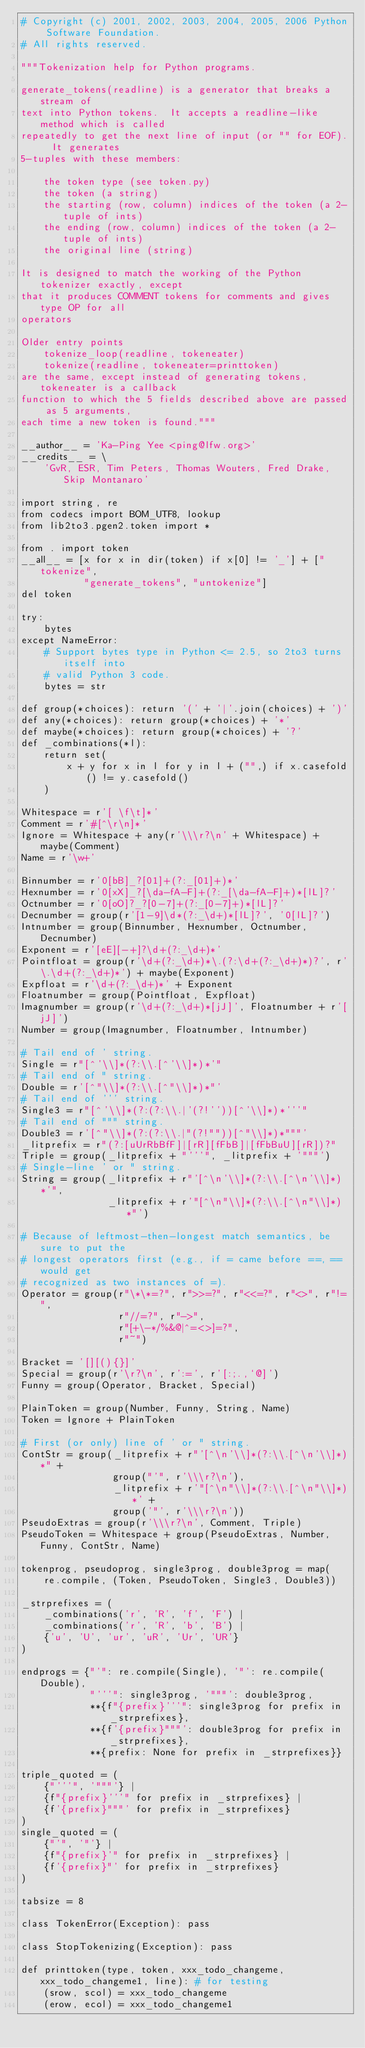<code> <loc_0><loc_0><loc_500><loc_500><_Python_># Copyright (c) 2001, 2002, 2003, 2004, 2005, 2006 Python Software Foundation.
# All rights reserved.

"""Tokenization help for Python programs.

generate_tokens(readline) is a generator that breaks a stream of
text into Python tokens.  It accepts a readline-like method which is called
repeatedly to get the next line of input (or "" for EOF).  It generates
5-tuples with these members:

    the token type (see token.py)
    the token (a string)
    the starting (row, column) indices of the token (a 2-tuple of ints)
    the ending (row, column) indices of the token (a 2-tuple of ints)
    the original line (string)

It is designed to match the working of the Python tokenizer exactly, except
that it produces COMMENT tokens for comments and gives type OP for all
operators

Older entry points
    tokenize_loop(readline, tokeneater)
    tokenize(readline, tokeneater=printtoken)
are the same, except instead of generating tokens, tokeneater is a callback
function to which the 5 fields described above are passed as 5 arguments,
each time a new token is found."""

__author__ = 'Ka-Ping Yee <ping@lfw.org>'
__credits__ = \
    'GvR, ESR, Tim Peters, Thomas Wouters, Fred Drake, Skip Montanaro'

import string, re
from codecs import BOM_UTF8, lookup
from lib2to3.pgen2.token import *

from . import token
__all__ = [x for x in dir(token) if x[0] != '_'] + ["tokenize",
           "generate_tokens", "untokenize"]
del token

try:
    bytes
except NameError:
    # Support bytes type in Python <= 2.5, so 2to3 turns itself into
    # valid Python 3 code.
    bytes = str

def group(*choices): return '(' + '|'.join(choices) + ')'
def any(*choices): return group(*choices) + '*'
def maybe(*choices): return group(*choices) + '?'
def _combinations(*l):
    return set(
        x + y for x in l for y in l + ("",) if x.casefold() != y.casefold()
    )

Whitespace = r'[ \f\t]*'
Comment = r'#[^\r\n]*'
Ignore = Whitespace + any(r'\\\r?\n' + Whitespace) + maybe(Comment)
Name = r'\w+'

Binnumber = r'0[bB]_?[01]+(?:_[01]+)*'
Hexnumber = r'0[xX]_?[\da-fA-F]+(?:_[\da-fA-F]+)*[lL]?'
Octnumber = r'0[oO]?_?[0-7]+(?:_[0-7]+)*[lL]?'
Decnumber = group(r'[1-9]\d*(?:_\d+)*[lL]?', '0[lL]?')
Intnumber = group(Binnumber, Hexnumber, Octnumber, Decnumber)
Exponent = r'[eE][-+]?\d+(?:_\d+)*'
Pointfloat = group(r'\d+(?:_\d+)*\.(?:\d+(?:_\d+)*)?', r'\.\d+(?:_\d+)*') + maybe(Exponent)
Expfloat = r'\d+(?:_\d+)*' + Exponent
Floatnumber = group(Pointfloat, Expfloat)
Imagnumber = group(r'\d+(?:_\d+)*[jJ]', Floatnumber + r'[jJ]')
Number = group(Imagnumber, Floatnumber, Intnumber)

# Tail end of ' string.
Single = r"[^'\\]*(?:\\.[^'\\]*)*'"
# Tail end of " string.
Double = r'[^"\\]*(?:\\.[^"\\]*)*"'
# Tail end of ''' string.
Single3 = r"[^'\\]*(?:(?:\\.|'(?!''))[^'\\]*)*'''"
# Tail end of """ string.
Double3 = r'[^"\\]*(?:(?:\\.|"(?!""))[^"\\]*)*"""'
_litprefix = r"(?:[uUrRbBfF]|[rR][fFbB]|[fFbBuU][rR])?"
Triple = group(_litprefix + "'''", _litprefix + '"""')
# Single-line ' or " string.
String = group(_litprefix + r"'[^\n'\\]*(?:\\.[^\n'\\]*)*'",
               _litprefix + r'"[^\n"\\]*(?:\\.[^\n"\\]*)*"')

# Because of leftmost-then-longest match semantics, be sure to put the
# longest operators first (e.g., if = came before ==, == would get
# recognized as two instances of =).
Operator = group(r"\*\*=?", r">>=?", r"<<=?", r"<>", r"!=",
                 r"//=?", r"->",
                 r"[+\-*/%&@|^=<>]=?",
                 r"~")

Bracket = '[][(){}]'
Special = group(r'\r?\n', r':=', r'[:;.,`@]')
Funny = group(Operator, Bracket, Special)

PlainToken = group(Number, Funny, String, Name)
Token = Ignore + PlainToken

# First (or only) line of ' or " string.
ContStr = group(_litprefix + r"'[^\n'\\]*(?:\\.[^\n'\\]*)*" +
                group("'", r'\\\r?\n'),
                _litprefix + r'"[^\n"\\]*(?:\\.[^\n"\\]*)*' +
                group('"', r'\\\r?\n'))
PseudoExtras = group(r'\\\r?\n', Comment, Triple)
PseudoToken = Whitespace + group(PseudoExtras, Number, Funny, ContStr, Name)

tokenprog, pseudoprog, single3prog, double3prog = map(
    re.compile, (Token, PseudoToken, Single3, Double3))

_strprefixes = (
    _combinations('r', 'R', 'f', 'F') |
    _combinations('r', 'R', 'b', 'B') |
    {'u', 'U', 'ur', 'uR', 'Ur', 'UR'}
)

endprogs = {"'": re.compile(Single), '"': re.compile(Double),
            "'''": single3prog, '"""': double3prog,
            **{f"{prefix}'''": single3prog for prefix in _strprefixes},
            **{f'{prefix}"""': double3prog for prefix in _strprefixes},
            **{prefix: None for prefix in _strprefixes}}

triple_quoted = (
    {"'''", '"""'} |
    {f"{prefix}'''" for prefix in _strprefixes} |
    {f'{prefix}"""' for prefix in _strprefixes}
)
single_quoted = (
    {"'", '"'} |
    {f"{prefix}'" for prefix in _strprefixes} |
    {f'{prefix}"' for prefix in _strprefixes}
)

tabsize = 8

class TokenError(Exception): pass

class StopTokenizing(Exception): pass

def printtoken(type, token, xxx_todo_changeme, xxx_todo_changeme1, line): # for testing
    (srow, scol) = xxx_todo_changeme
    (erow, ecol) = xxx_todo_changeme1</code> 